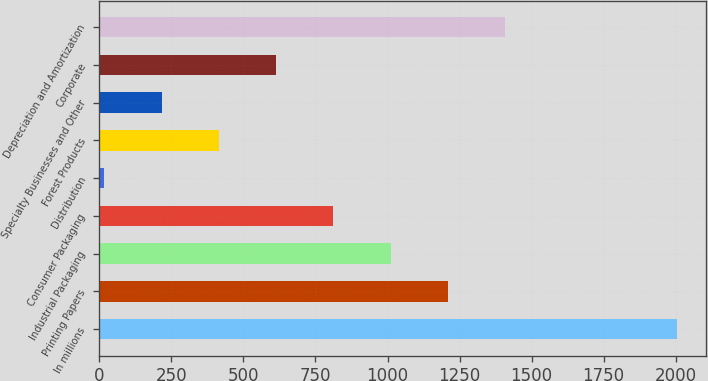Convert chart. <chart><loc_0><loc_0><loc_500><loc_500><bar_chart><fcel>In millions<fcel>Printing Papers<fcel>Industrial Packaging<fcel>Consumer Packaging<fcel>Distribution<fcel>Forest Products<fcel>Specialty Businesses and Other<fcel>Corporate<fcel>Depreciation and Amortization<nl><fcel>2004<fcel>1209.2<fcel>1010.5<fcel>811.8<fcel>17<fcel>414.4<fcel>215.7<fcel>613.1<fcel>1407.9<nl></chart> 